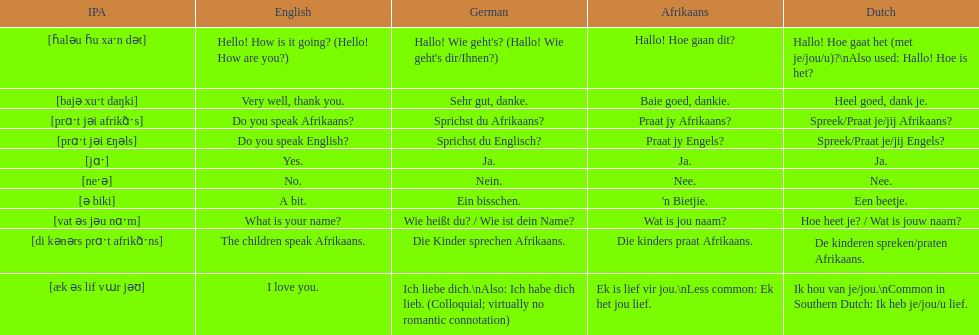Translate the following into english: 'n bietjie. A bit. 